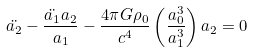<formula> <loc_0><loc_0><loc_500><loc_500>\ddot { a _ { 2 } } - \frac { \ddot { a _ { 1 } } a _ { 2 } } { a _ { 1 } } - \frac { 4 \pi G \rho _ { 0 } } { c ^ { 4 } } \left ( \frac { a _ { 0 } ^ { 3 } } { a _ { 1 } ^ { 3 } } \right ) a _ { 2 } = 0</formula> 